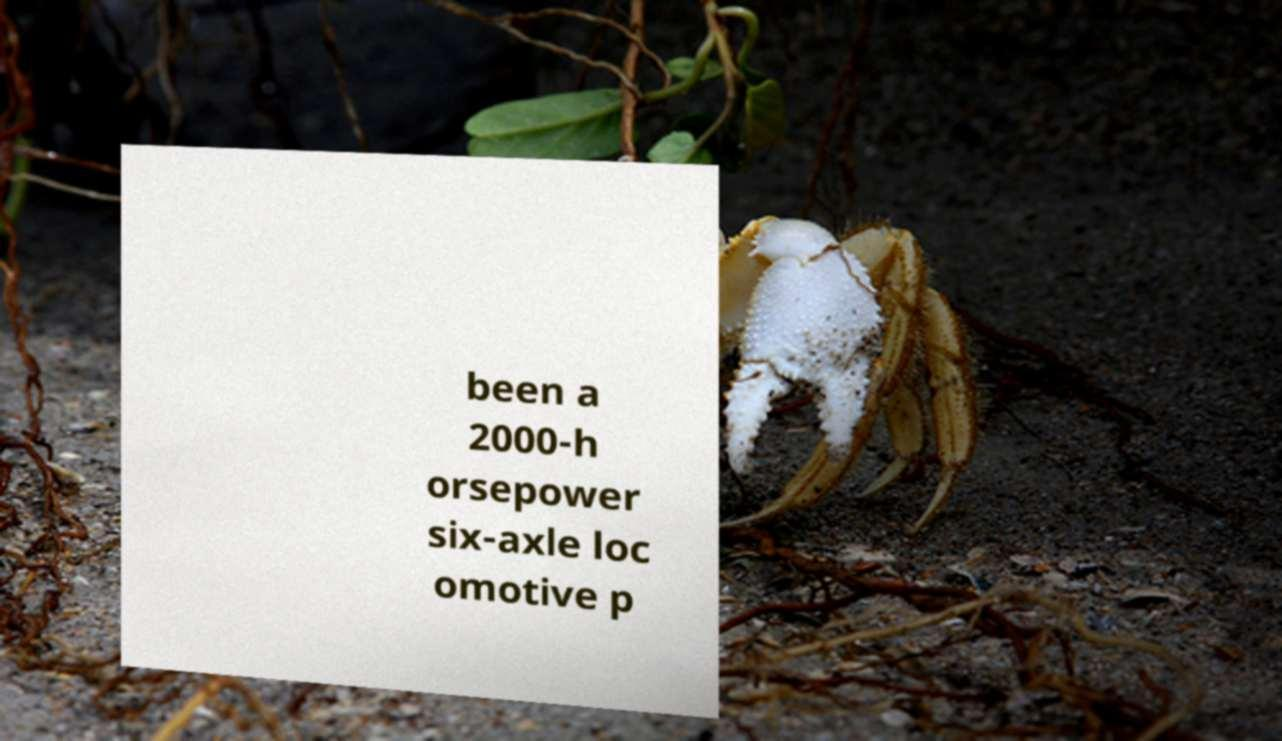There's text embedded in this image that I need extracted. Can you transcribe it verbatim? been a 2000-h orsepower six-axle loc omotive p 